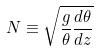Convert formula to latex. <formula><loc_0><loc_0><loc_500><loc_500>N \equiv \sqrt { \frac { g } { \theta } \frac { d \theta } { d z } }</formula> 